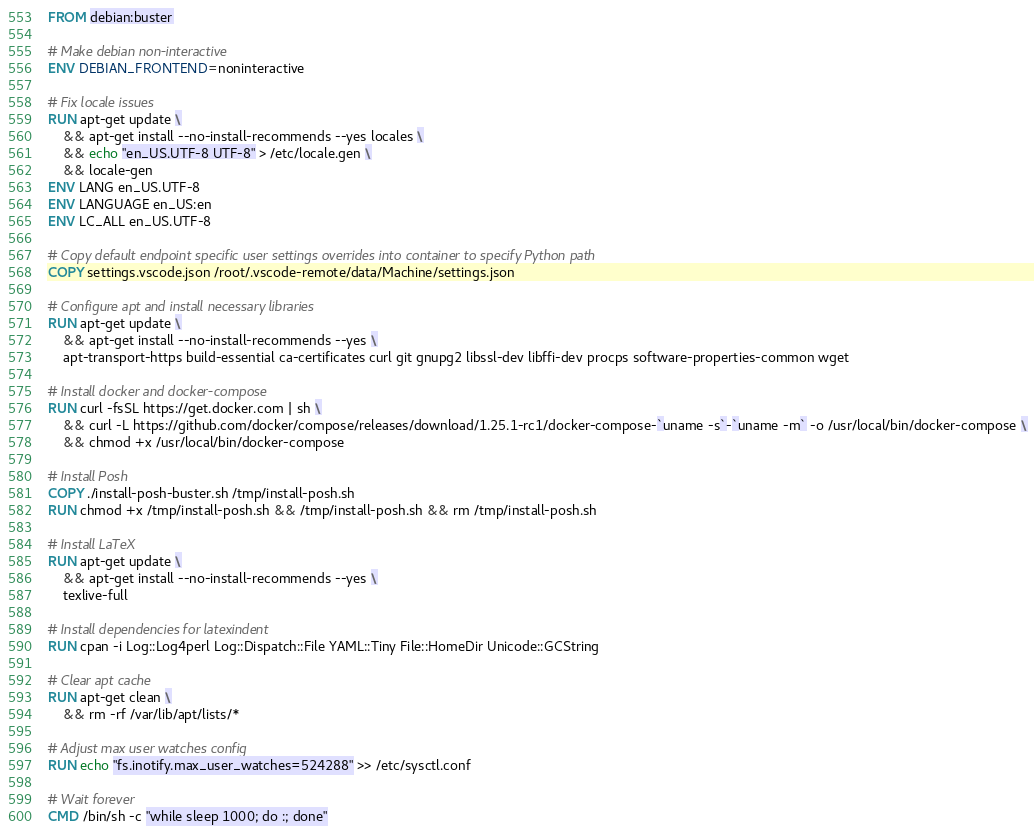Convert code to text. <code><loc_0><loc_0><loc_500><loc_500><_Dockerfile_>FROM debian:buster

# Make debian non-interactive
ENV DEBIAN_FRONTEND=noninteractive

# Fix locale issues
RUN apt-get update \
    && apt-get install --no-install-recommends --yes locales \
    && echo "en_US.UTF-8 UTF-8" > /etc/locale.gen \
    && locale-gen
ENV LANG en_US.UTF-8
ENV LANGUAGE en_US:en
ENV LC_ALL en_US.UTF-8

# Copy default endpoint specific user settings overrides into container to specify Python path
COPY settings.vscode.json /root/.vscode-remote/data/Machine/settings.json

# Configure apt and install necessary libraries
RUN apt-get update \
    && apt-get install --no-install-recommends --yes \
    apt-transport-https build-essential ca-certificates curl git gnupg2 libssl-dev libffi-dev procps software-properties-common wget

# Install docker and docker-compose
RUN curl -fsSL https://get.docker.com | sh \
    && curl -L https://github.com/docker/compose/releases/download/1.25.1-rc1/docker-compose-`uname -s`-`uname -m` -o /usr/local/bin/docker-compose \
    && chmod +x /usr/local/bin/docker-compose

# Install Posh
COPY ./install-posh-buster.sh /tmp/install-posh.sh
RUN chmod +x /tmp/install-posh.sh && /tmp/install-posh.sh && rm /tmp/install-posh.sh

# Install LaTeX
RUN apt-get update \
    && apt-get install --no-install-recommends --yes \
    texlive-full

# Install dependencies for latexindent
RUN cpan -i Log::Log4perl Log::Dispatch::File YAML::Tiny File::HomeDir Unicode::GCString

# Clear apt cache
RUN apt-get clean \
    && rm -rf /var/lib/apt/lists/*

# Adjust max user watches config
RUN echo "fs.inotify.max_user_watches=524288" >> /etc/sysctl.conf

# Wait forever
CMD /bin/sh -c "while sleep 1000; do :; done"
</code> 